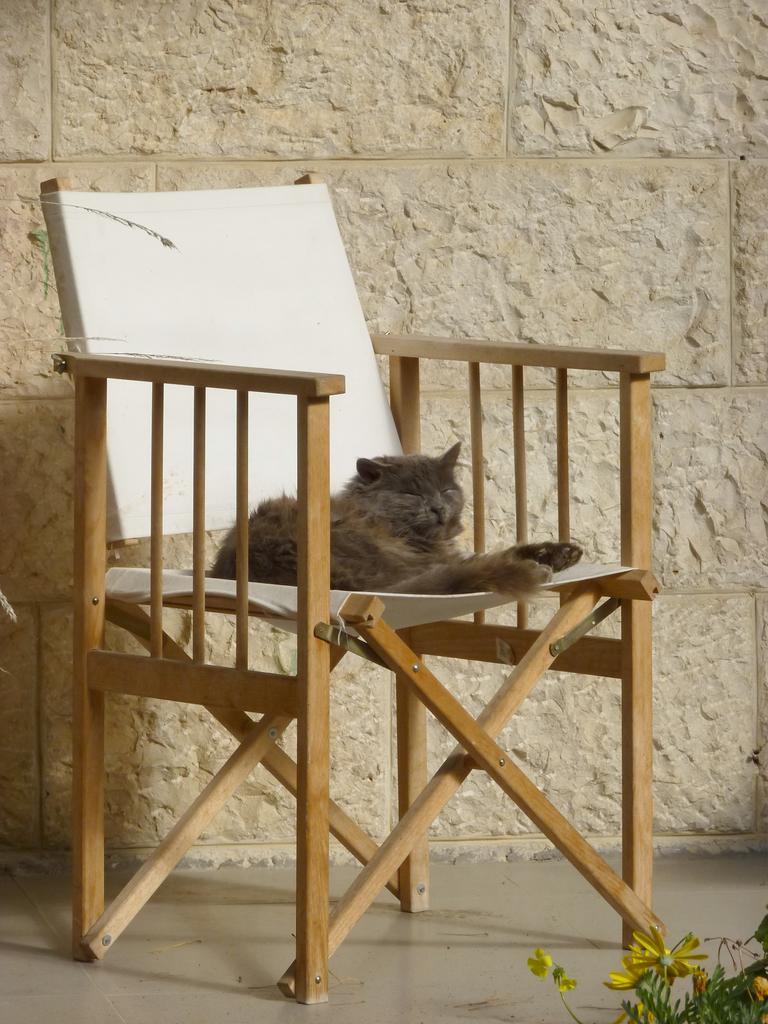How would you summarize this image in a sentence or two? In this image there is a cat sitting in a white color chair , and in background there is a wall, and a plant ,and flower. 